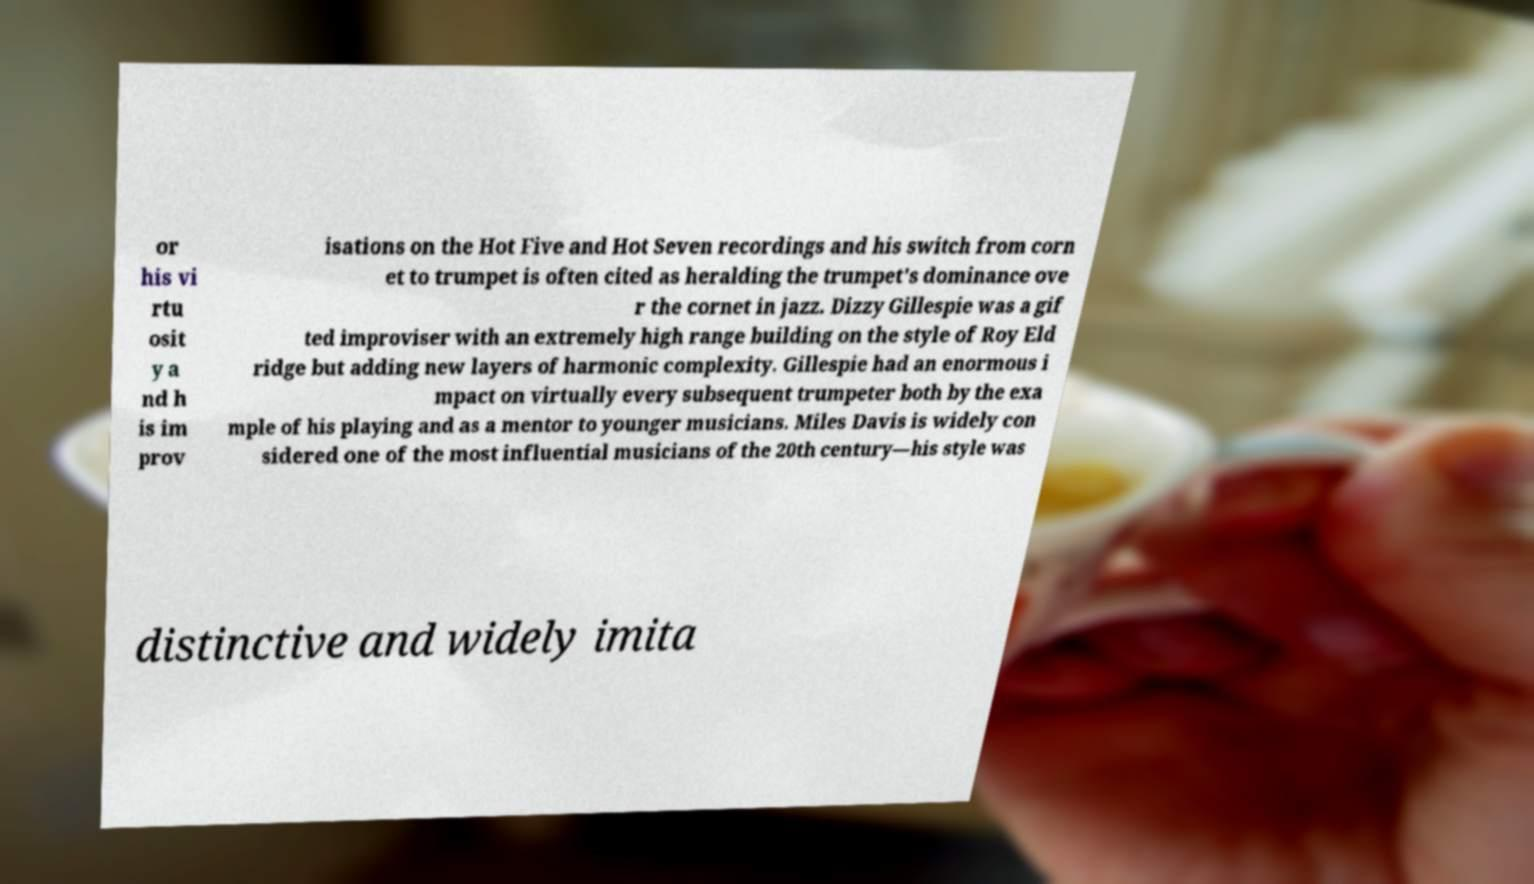Please read and relay the text visible in this image. What does it say? or his vi rtu osit y a nd h is im prov isations on the Hot Five and Hot Seven recordings and his switch from corn et to trumpet is often cited as heralding the trumpet's dominance ove r the cornet in jazz. Dizzy Gillespie was a gif ted improviser with an extremely high range building on the style of Roy Eld ridge but adding new layers of harmonic complexity. Gillespie had an enormous i mpact on virtually every subsequent trumpeter both by the exa mple of his playing and as a mentor to younger musicians. Miles Davis is widely con sidered one of the most influential musicians of the 20th century—his style was distinctive and widely imita 